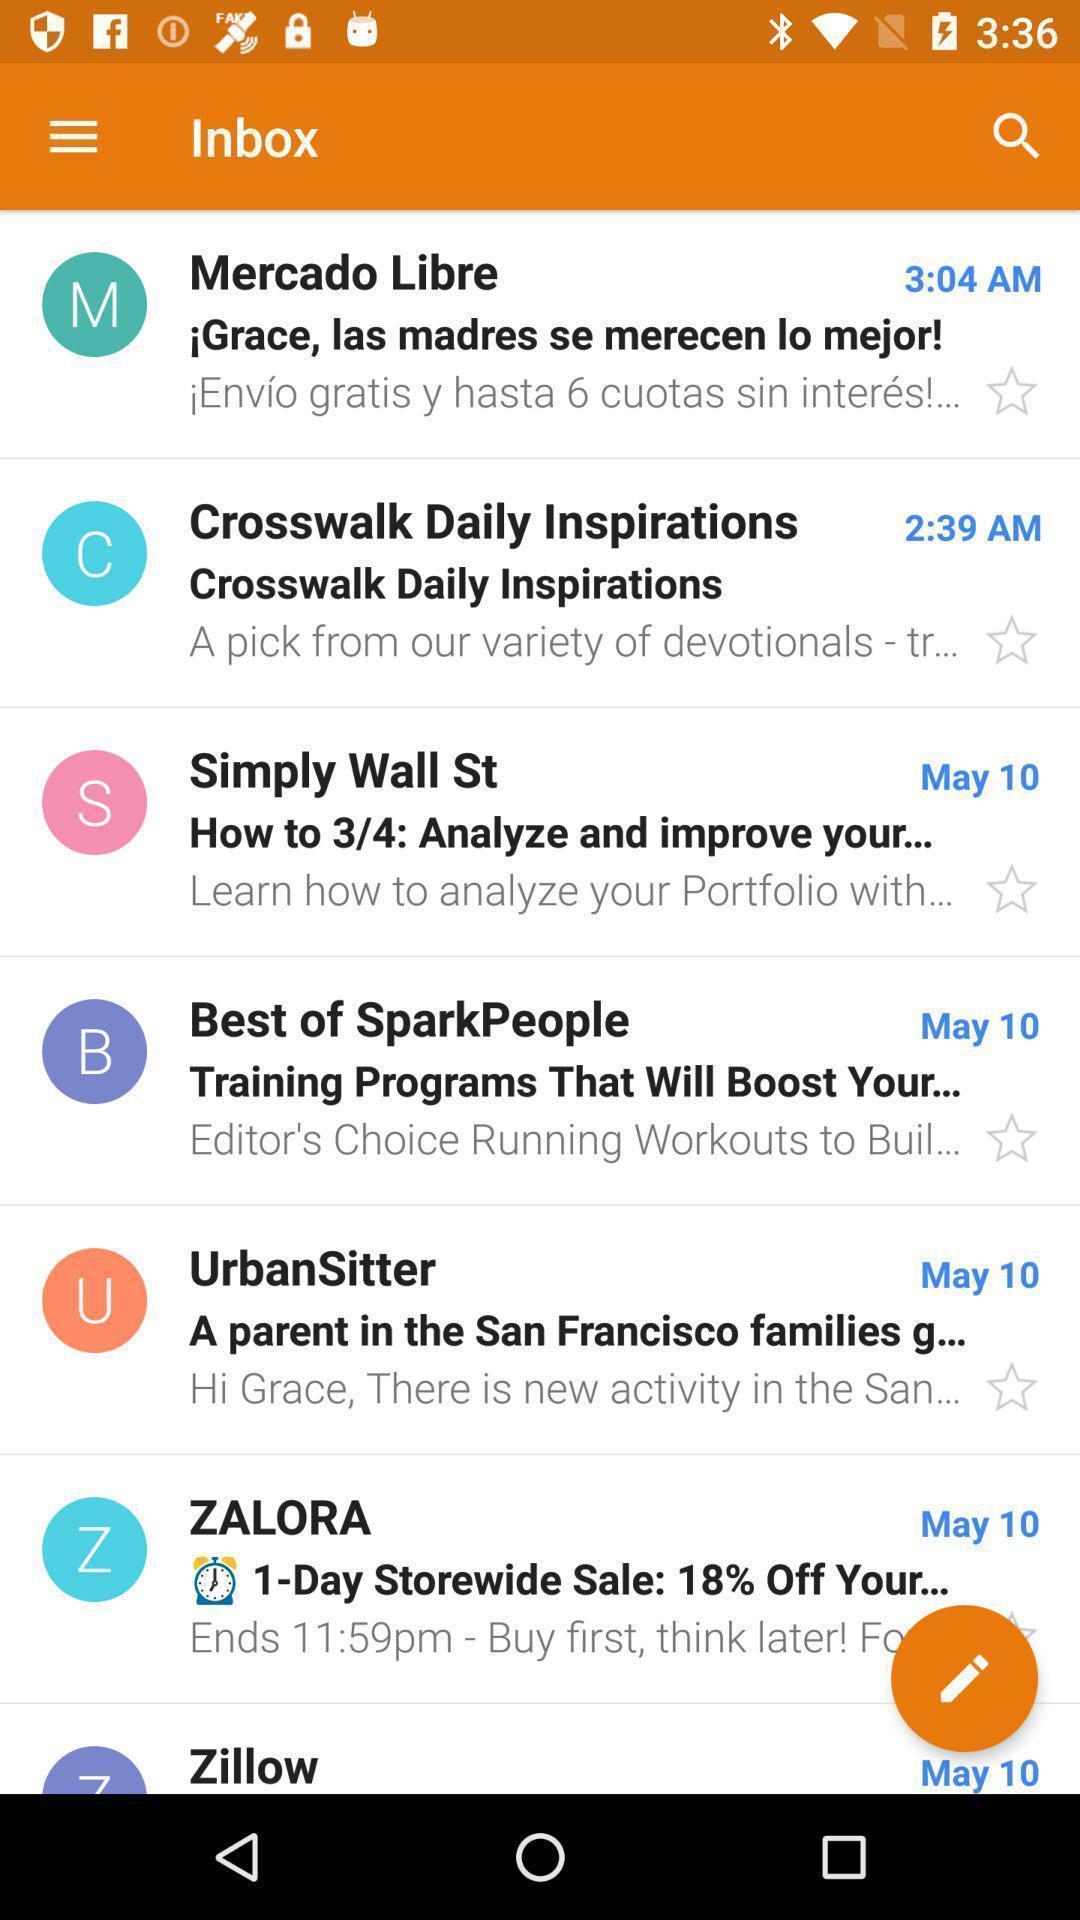Give me a narrative description of this picture. Page showing list of mails in inbox. 